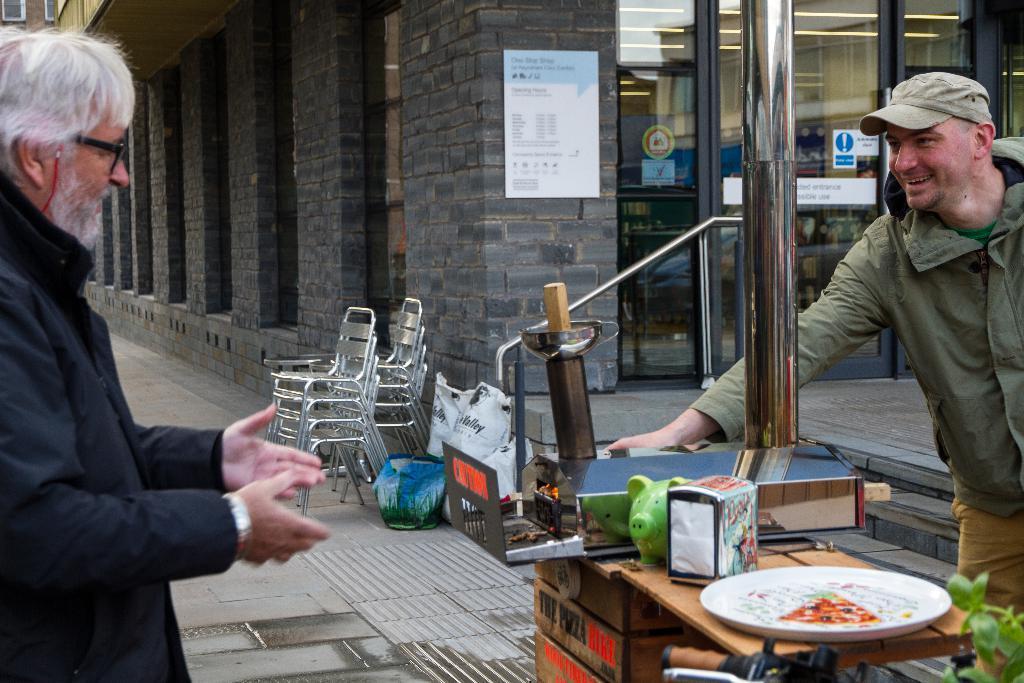How would you summarize this image in a sentence or two? On the left side there is a person wearing specs. On the right side there is a person wearing jacket and cap. Near to him there is a table. On that there is a plate, box and many other things. In the back there are packets, chairs and a building with brick wall. On the wall there is a poster. 